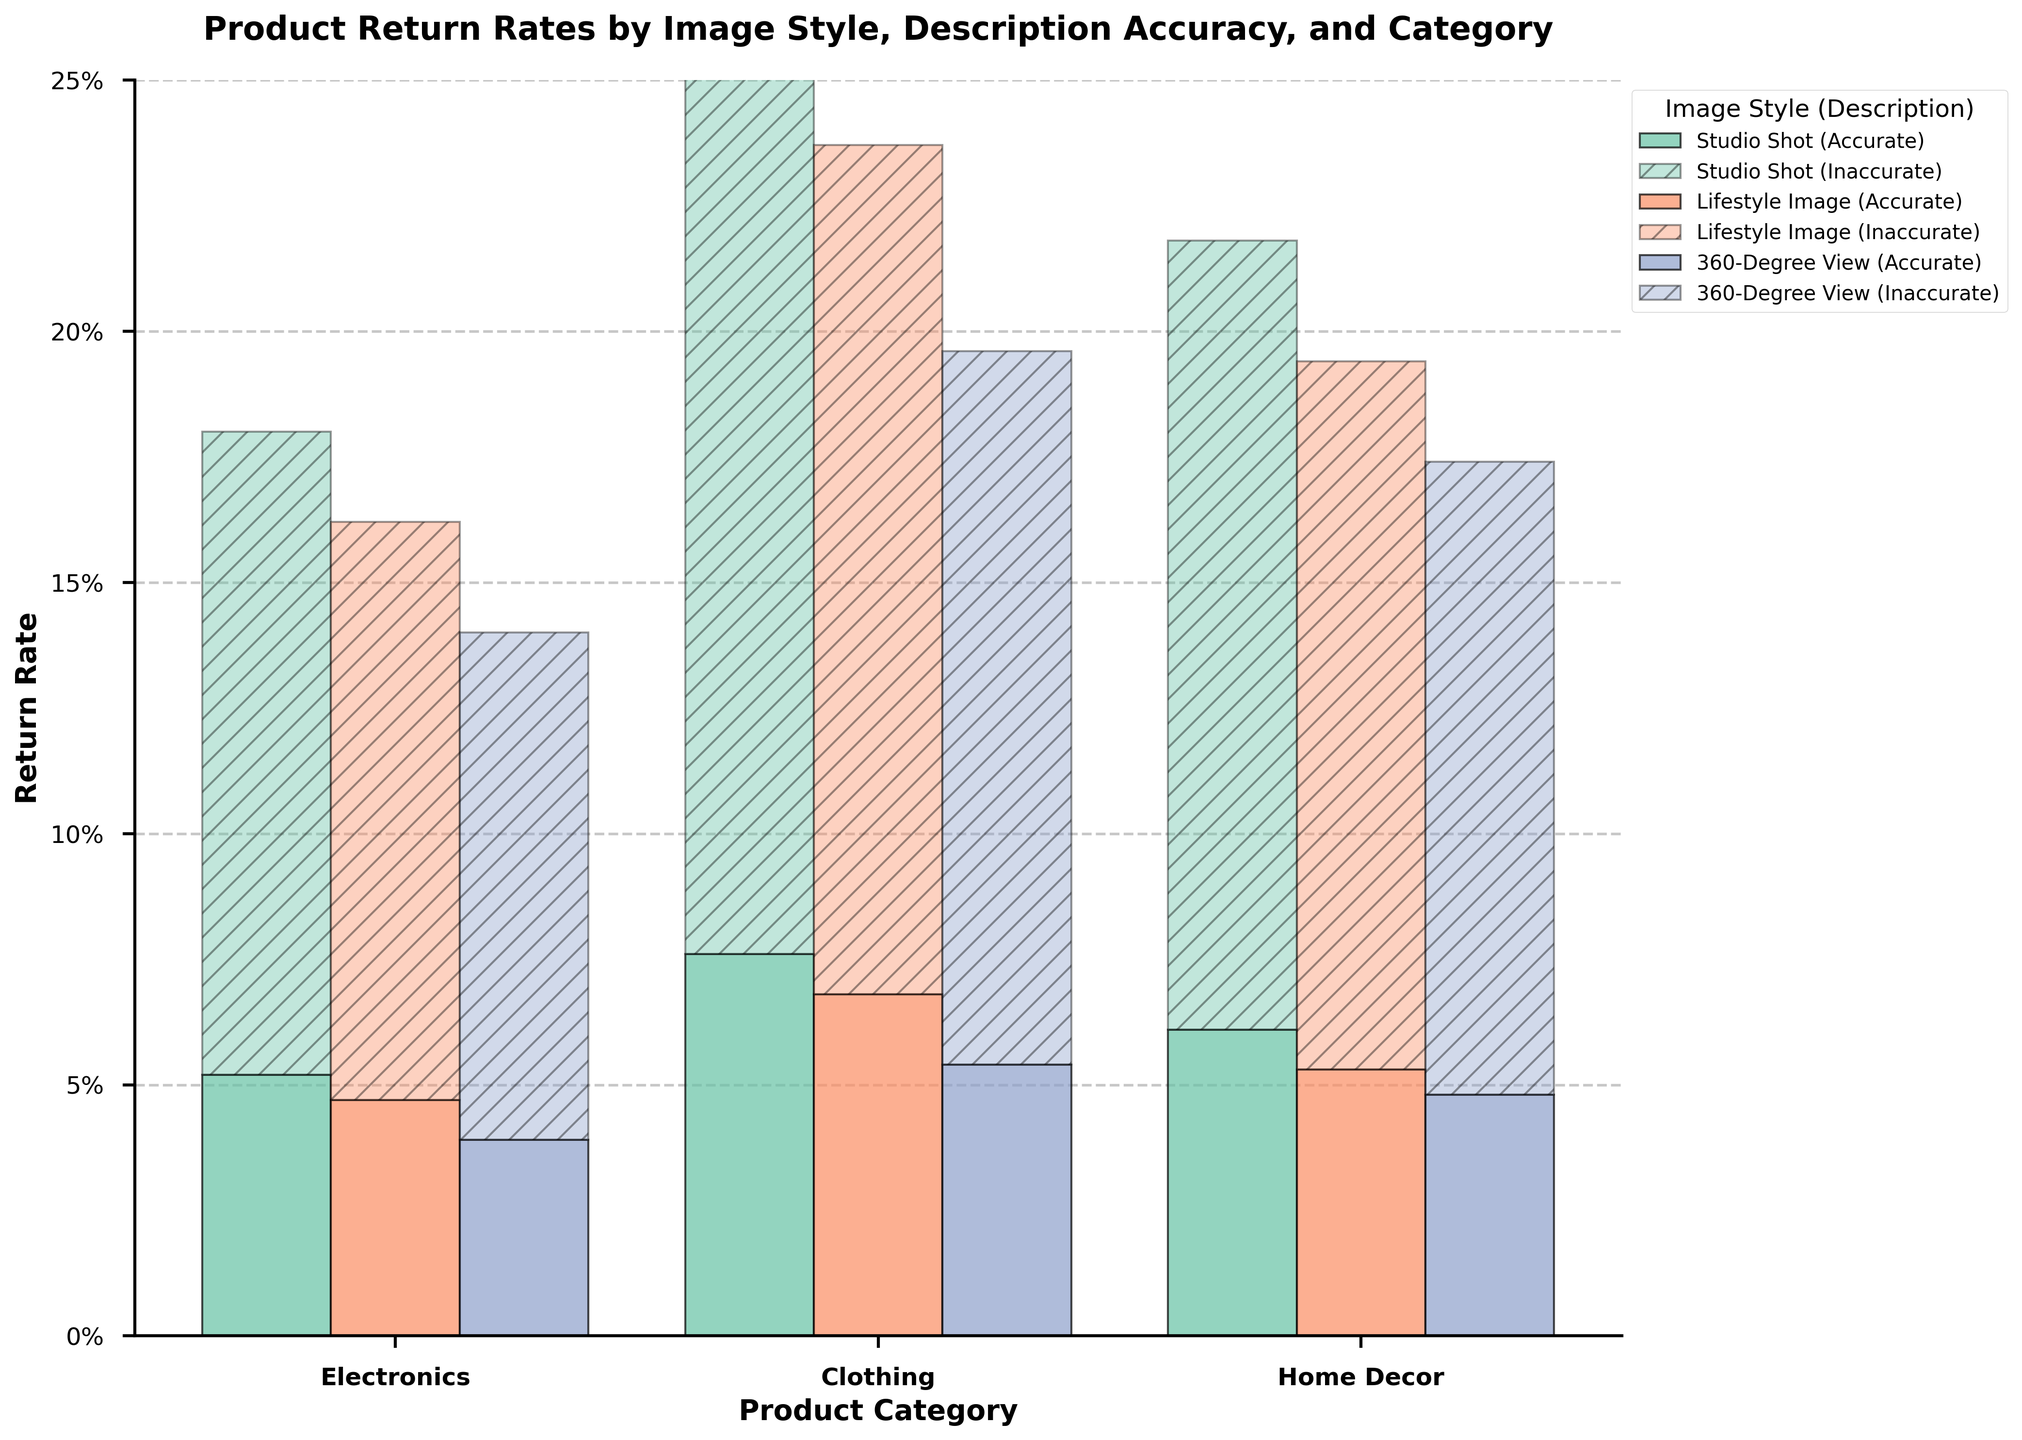What is the return rate for Electronics when the image style is a Studio Shot and the description is inaccurate? Locate the bar representing Electronics with Studio Shot and Inaccurate Description. The length of this bar indicates the return rate.
Answer: 12.8% How does the return rate for Clothing with Lifestyle Image and Accurate Description compare to Home Decor with the same conditions? Compare the heights of the bars for Clothing and Home Decor under Lifestyle Image and Accurate Description.
Answer: Clothing: 6.8%, Home Decor: 5.3% What is the combined return rate for Electronics with any image style when the descriptions are accurate versus inaccurate? Sum the return rates for all image styles under "Accurate" and "Inaccurate" descriptions specifically for Electronics. Accurate: 5.2% + 4.7% + 3.9% = 13.8%, Inaccurate: 12.8% + 11.5% + 10.1% = 34.4%.
Answer: Accurate: 13.8%, Inaccurate: 34.4% Which product category and image style combination has the lowest return rate? Identify the shortest bar across all product categories and image styles.
Answer: Electronics with 360-Degree View and Accurate Description (3.9%) What is the average return rate for Home Decor across all image styles and description accuracies? Calculate the average by summing all return rates for Home Decor and dividing by the number of data points (6). (6.1% + 15.7% + 5.3% + 14.1% + 4.8% + 12.6%) / 6 = 58.6% / 6 = 9.77%
Answer: 9.77% How much higher is the return rate for Clothing with Studio Shot and Inaccurate Description compared to Clothing with 360-Degree View and Accurate Description? Find the return rates for both conditions and subtract the smaller one from the larger one: 18.3% - 5.4%
Answer: 12.9% Which image style consistently shows the lowest return rates across all product categories when descriptions are accurate? Examine the lowest bars for each product category under accurate description conditions and identify the common image style.
Answer: 360-Degree View What's the difference in return rates between Lifestyle Image and Studio Shot for Home Decor when descriptions are inaccurate? Subtract the return rate for Lifestyle Image from Studio Shot under inaccurate descriptions for Home Decor: 15.7% - 14.1%
Answer: 1.6% 